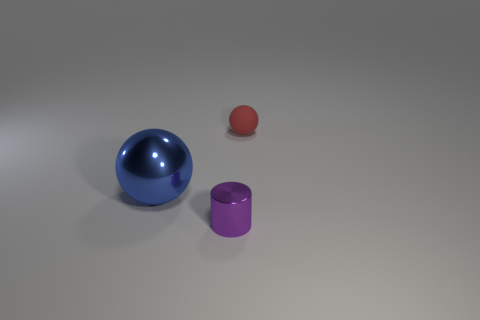Add 2 purple things. How many objects exist? 5 Subtract all balls. How many objects are left? 1 Add 3 matte things. How many matte things exist? 4 Subtract 0 red blocks. How many objects are left? 3 Subtract all red metallic spheres. Subtract all tiny red rubber things. How many objects are left? 2 Add 1 small metal cylinders. How many small metal cylinders are left? 2 